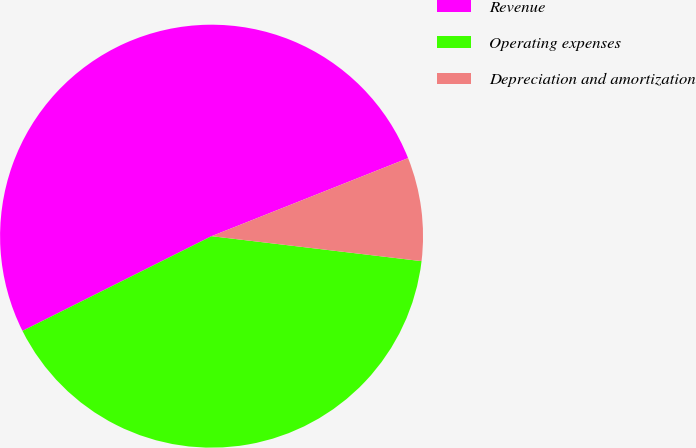Convert chart to OTSL. <chart><loc_0><loc_0><loc_500><loc_500><pie_chart><fcel>Revenue<fcel>Operating expenses<fcel>Depreciation and amortization<nl><fcel>51.38%<fcel>40.73%<fcel>7.9%<nl></chart> 